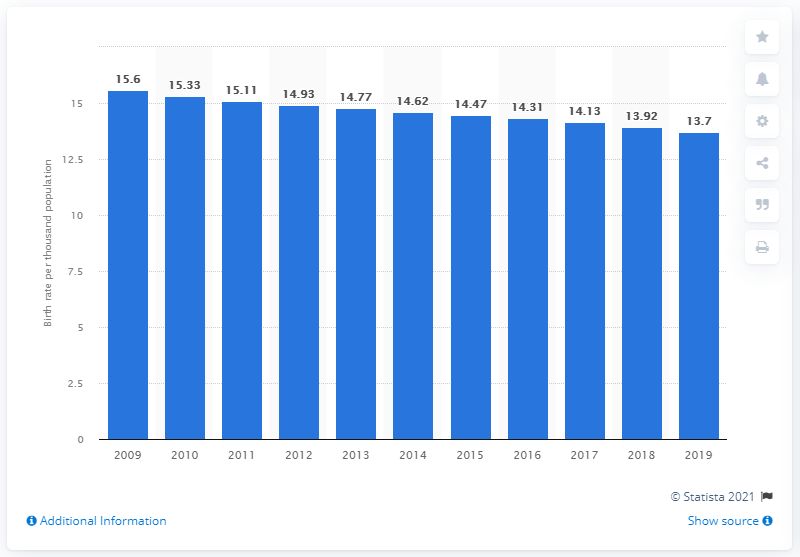Highlight a few significant elements in this photo. According to data from 2019, the crude birth rate in Brazil was 13.7 births per 1,000 population. 